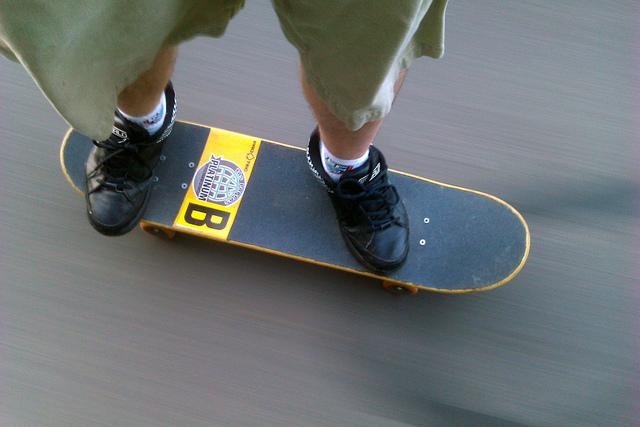Is this person wearing pants or shorts?
Keep it brief. Shorts. How well used is the skateboard?
Give a very brief answer. Slightly. Is the skateboard moving in this picture?
Be succinct. Yes. 